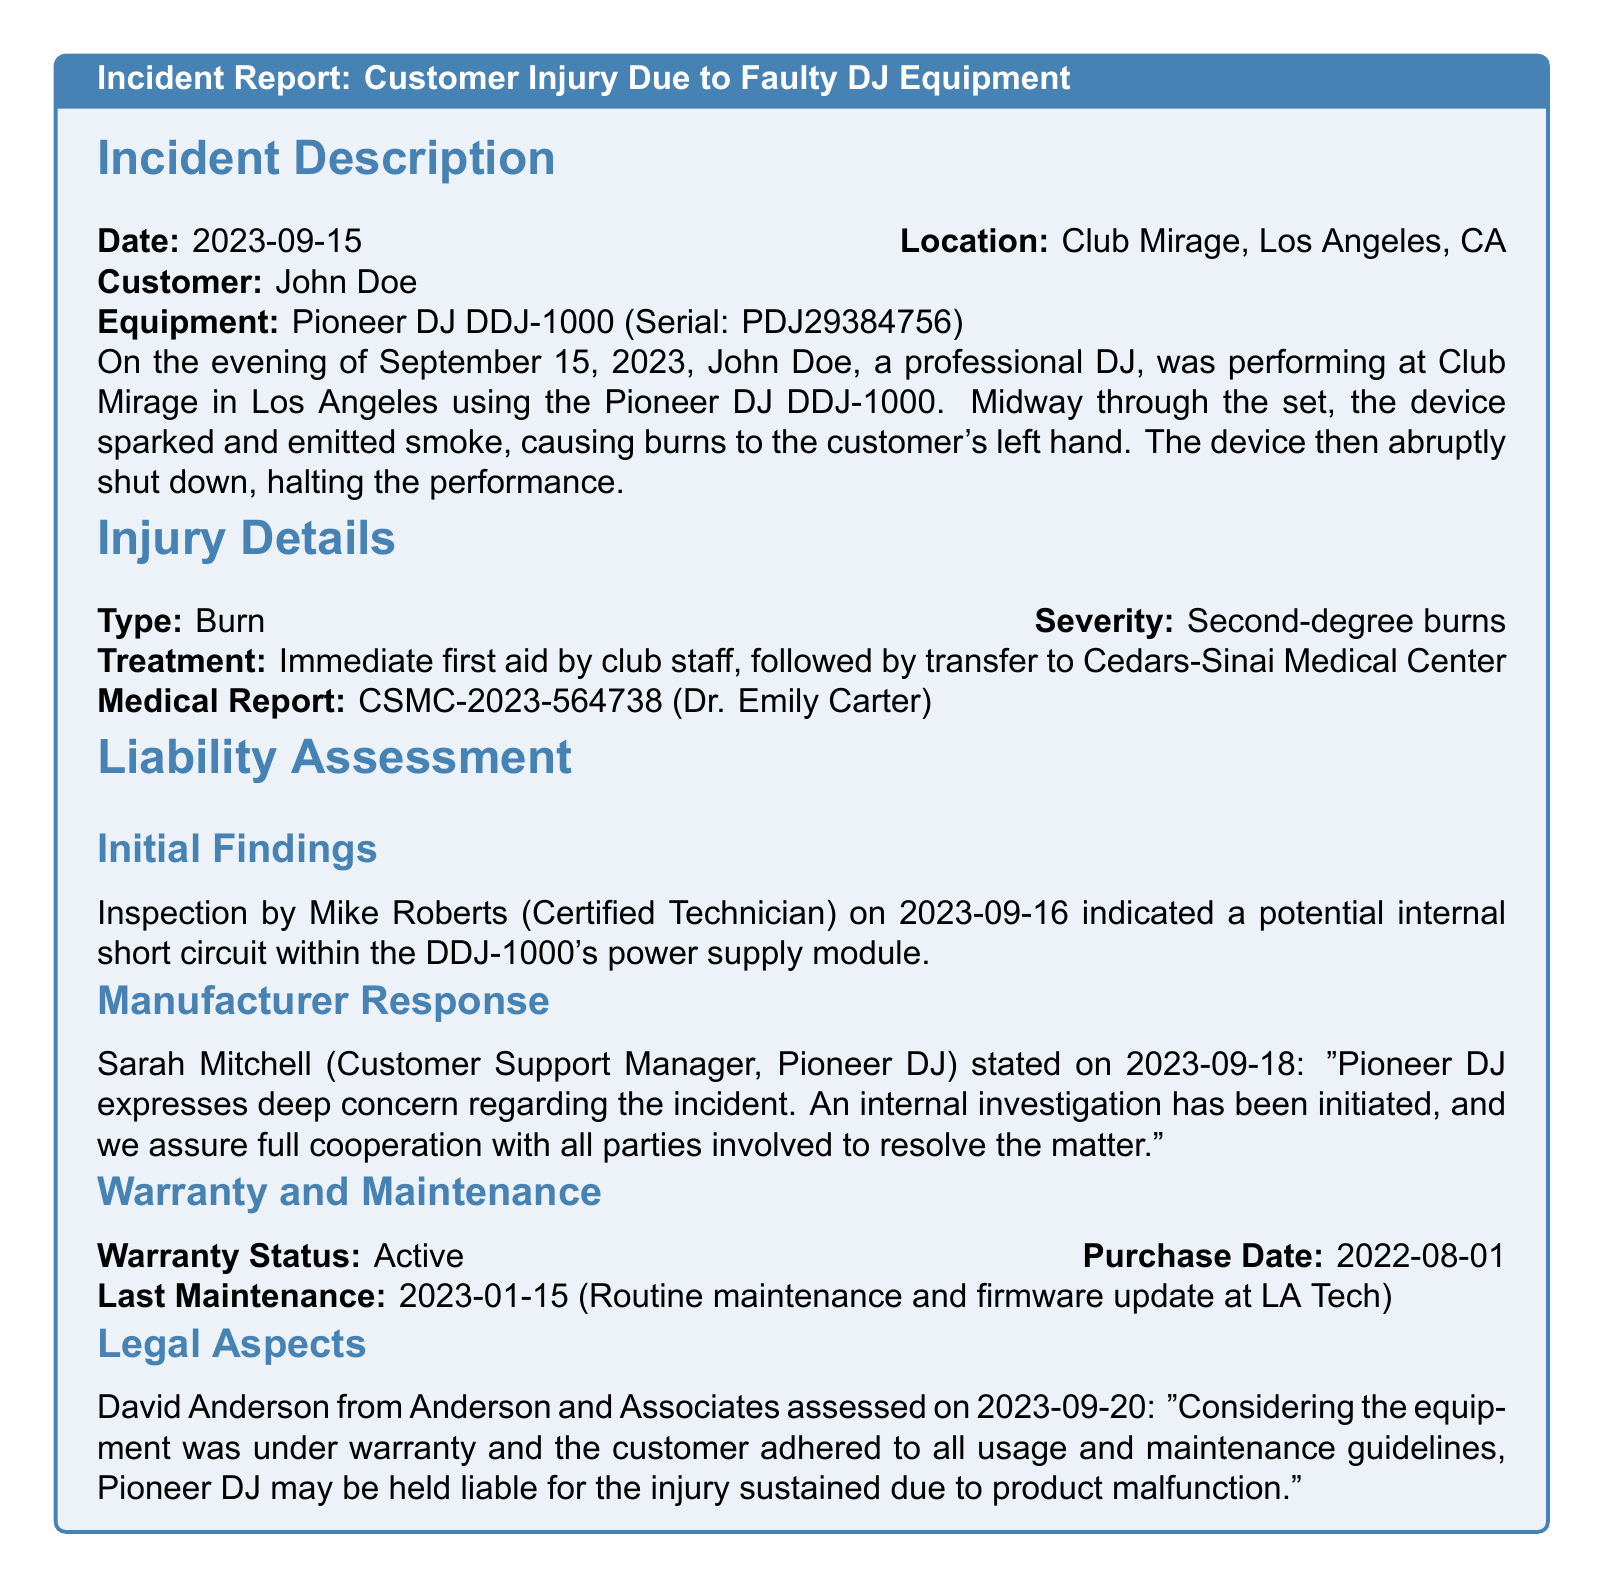What date did the incident occur? The incident occurred on September 15, 2023, as stated in the incident description section.
Answer: September 15, 2023 Who was the customer involved in the incident? The customer's name is provided in the incident description section.
Answer: John Doe What type of injury did the customer sustain? The type of injury is detailed in the injury details section of the report.
Answer: Burn What is the severity of the injury reported? The severity of the injury is specified in the injury details section.
Answer: Second-degree burns What was the cause of the equipment malfunction according to the technician? The technician's initial findings indicate a specific issue with the equipment, found in the liability assessment section.
Answer: Internal short circuit Which medical center was the customer transferred to? The medical center the customer was taken to is mentioned in the injury details section.
Answer: Cedars-Sinai Medical Center Who provided the statement regarding Pioneer DJ's response? The name of the customer support manager who stated the company's response is included in the document.
Answer: Sarah Mitchell What date was the last maintenance performed on the equipment? The last maintenance date is specified in the warranty and maintenance section.
Answer: January 15, 2023 What is the warranty status of the equipment? The warranty status is explicitly stated in the warranty and maintenance section of the report.
Answer: Active What conclusion did the legal assessment reach regarding liability? The legal assessment's conclusion about liability is summarized in the legal aspects section.
Answer: Pioneer DJ may be held liable 